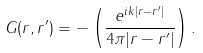<formula> <loc_0><loc_0><loc_500><loc_500>G ( { r , r ^ { \prime } } ) = - \left ( \frac { e ^ { i k | { r - r ^ { \prime } } | } } { 4 \pi | { r - r ^ { \prime } } | } \right ) .</formula> 